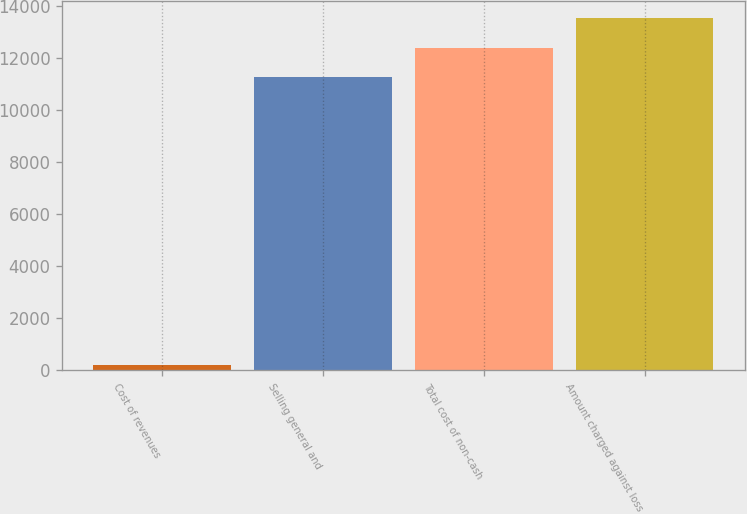<chart> <loc_0><loc_0><loc_500><loc_500><bar_chart><fcel>Cost of revenues<fcel>Selling general and<fcel>Total cost of non-cash<fcel>Amount charged against loss<nl><fcel>187<fcel>11282<fcel>12410.2<fcel>13538.4<nl></chart> 